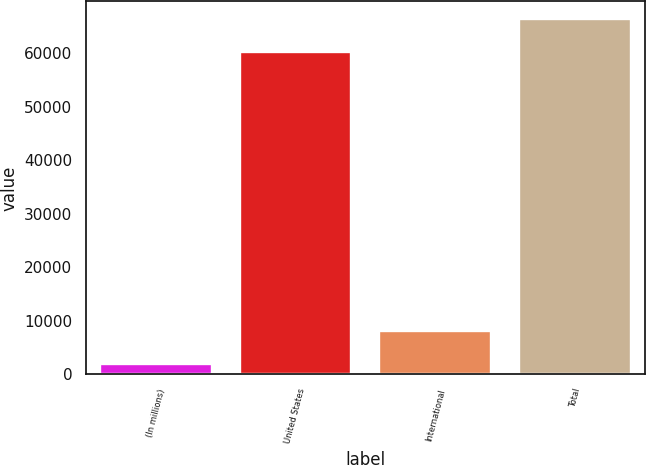Convert chart. <chart><loc_0><loc_0><loc_500><loc_500><bar_chart><fcel>(In millions)<fcel>United States<fcel>International<fcel>Total<nl><fcel>2005<fcel>60242<fcel>8103.1<fcel>66340.1<nl></chart> 